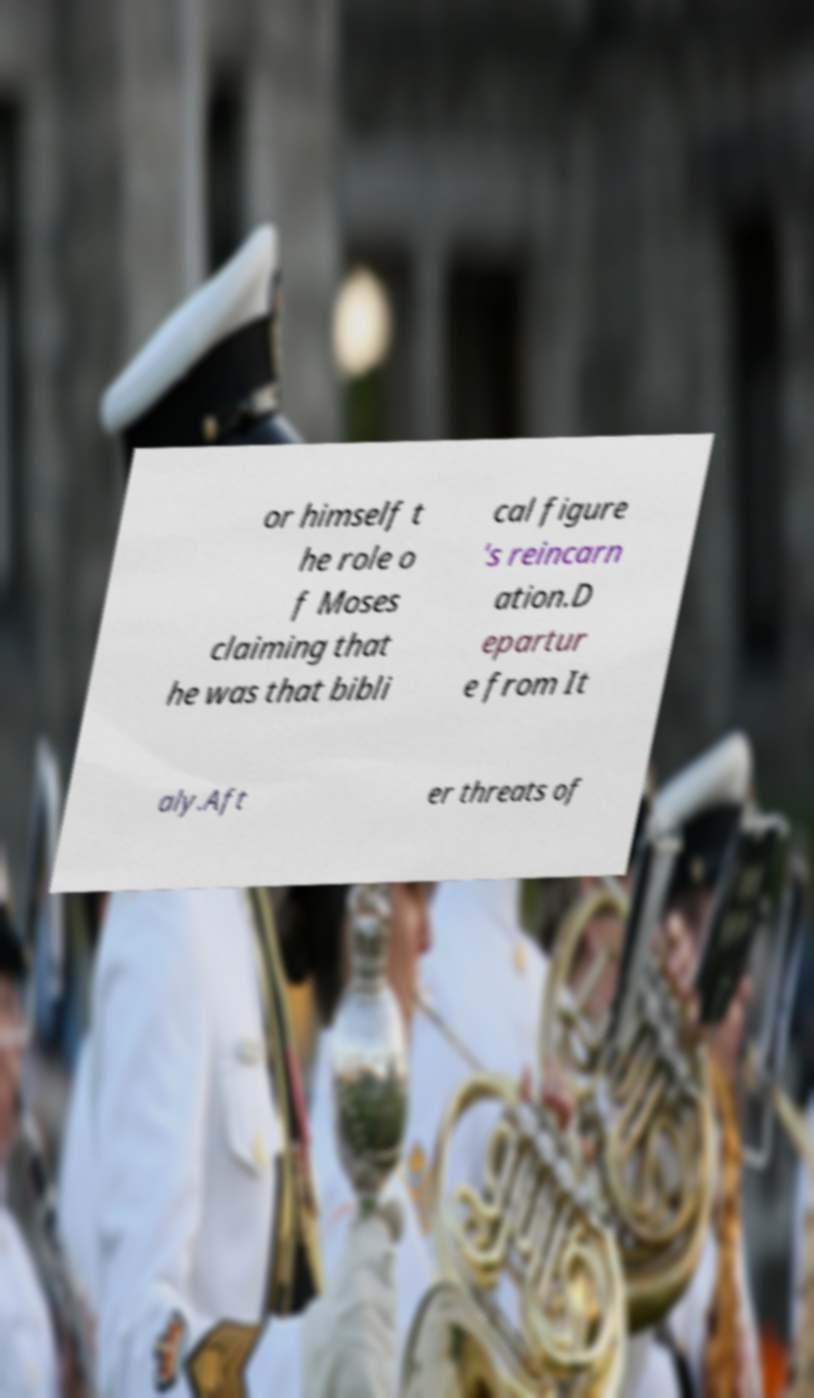What messages or text are displayed in this image? I need them in a readable, typed format. or himself t he role o f Moses claiming that he was that bibli cal figure 's reincarn ation.D epartur e from It aly.Aft er threats of 